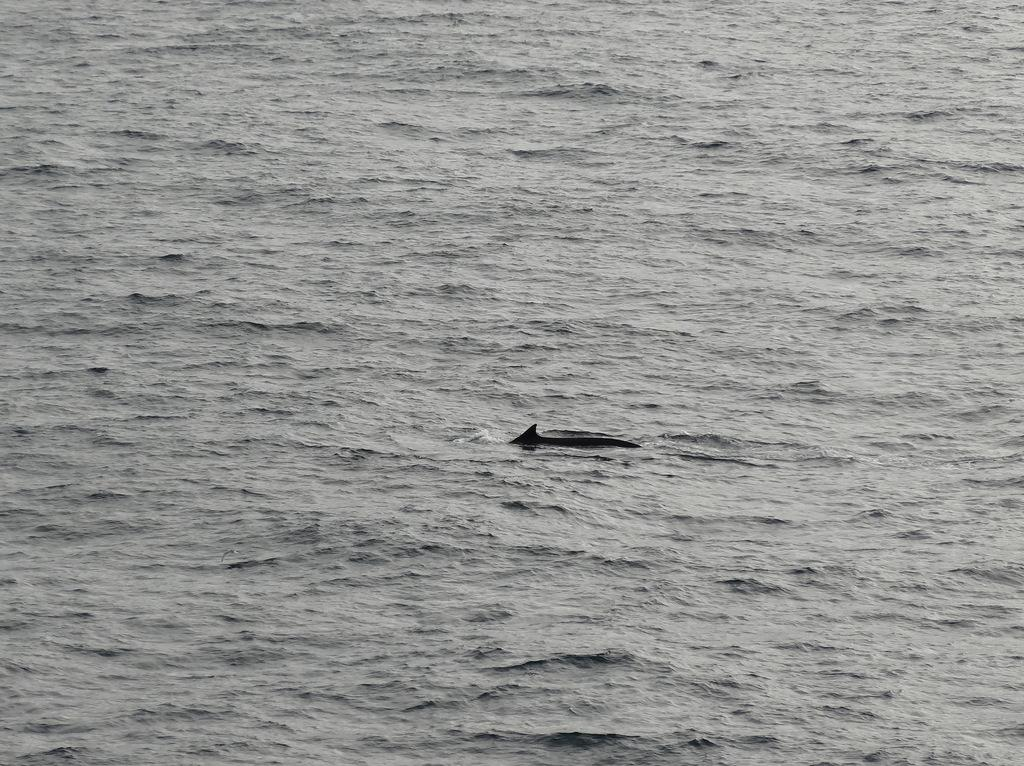What type of environment is depicted in the image? There is a sea in the image. What is happening in the sea? An animal is swimming in the sea. What statement does the stick make in the image? There is no stick present in the image, so it cannot make any statements. 